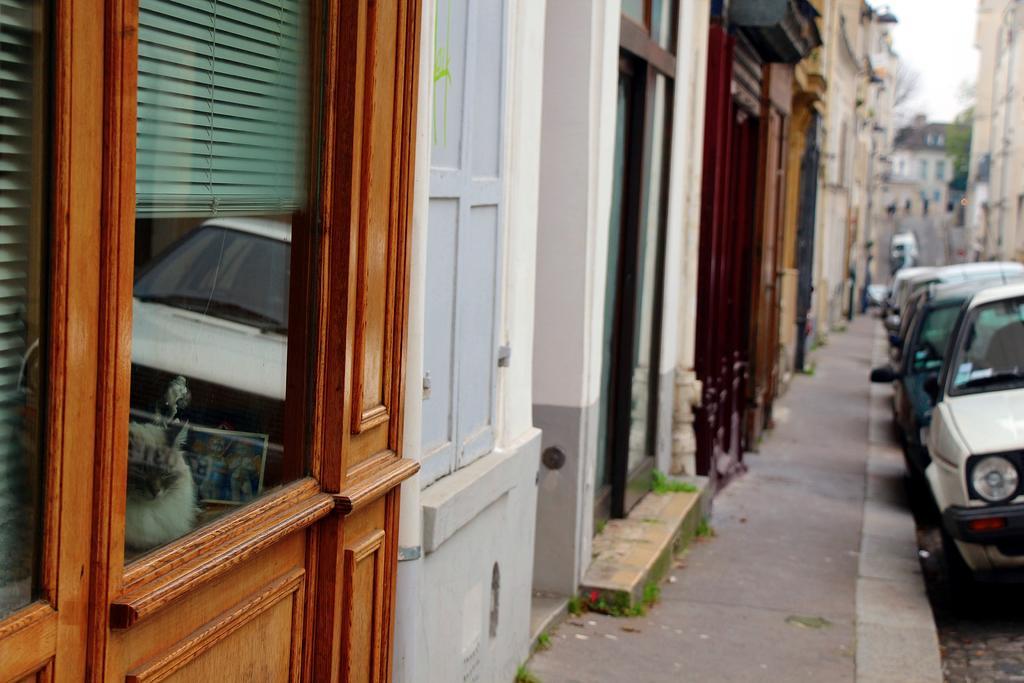Describe this image in one or two sentences. In the picture I can see buildings, glass windows through which I can see window blinds on the left side of the image. On the right side of the image I can see cars parked on the side of the road. The background of the image is slightly blurred, where I can see the sky. 